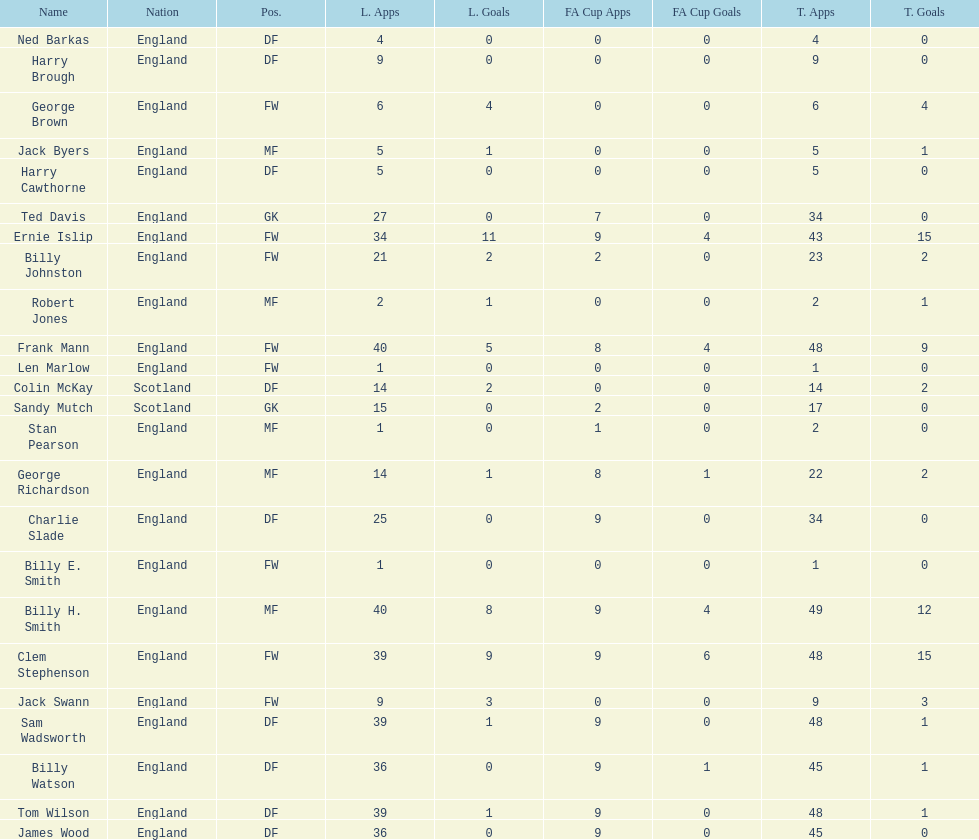What quantity of players falls under the fws category? 8. 